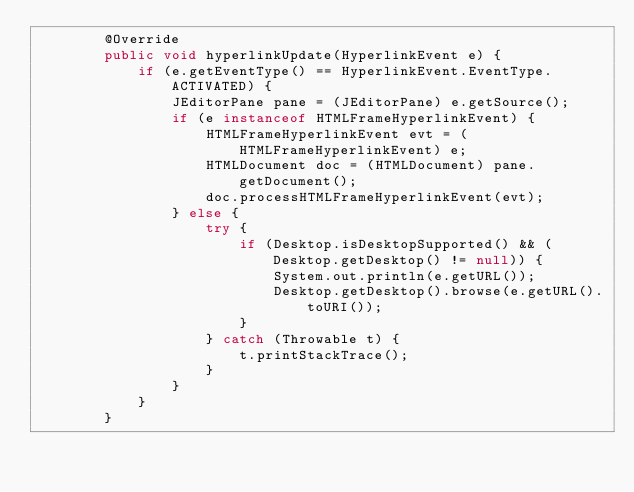Convert code to text. <code><loc_0><loc_0><loc_500><loc_500><_Java_>        @Override
        public void hyperlinkUpdate(HyperlinkEvent e) {
            if (e.getEventType() == HyperlinkEvent.EventType.ACTIVATED) {
                JEditorPane pane = (JEditorPane) e.getSource();
                if (e instanceof HTMLFrameHyperlinkEvent) {
                    HTMLFrameHyperlinkEvent evt = (HTMLFrameHyperlinkEvent) e;
                    HTMLDocument doc = (HTMLDocument) pane.getDocument();
                    doc.processHTMLFrameHyperlinkEvent(evt);
                } else {
                    try {
                        if (Desktop.isDesktopSupported() && (Desktop.getDesktop() != null)) {
                            System.out.println(e.getURL());
                            Desktop.getDesktop().browse(e.getURL().toURI());
                        }
                    } catch (Throwable t) {
                        t.printStackTrace();
                    }
                }
            }
        }
</code> 